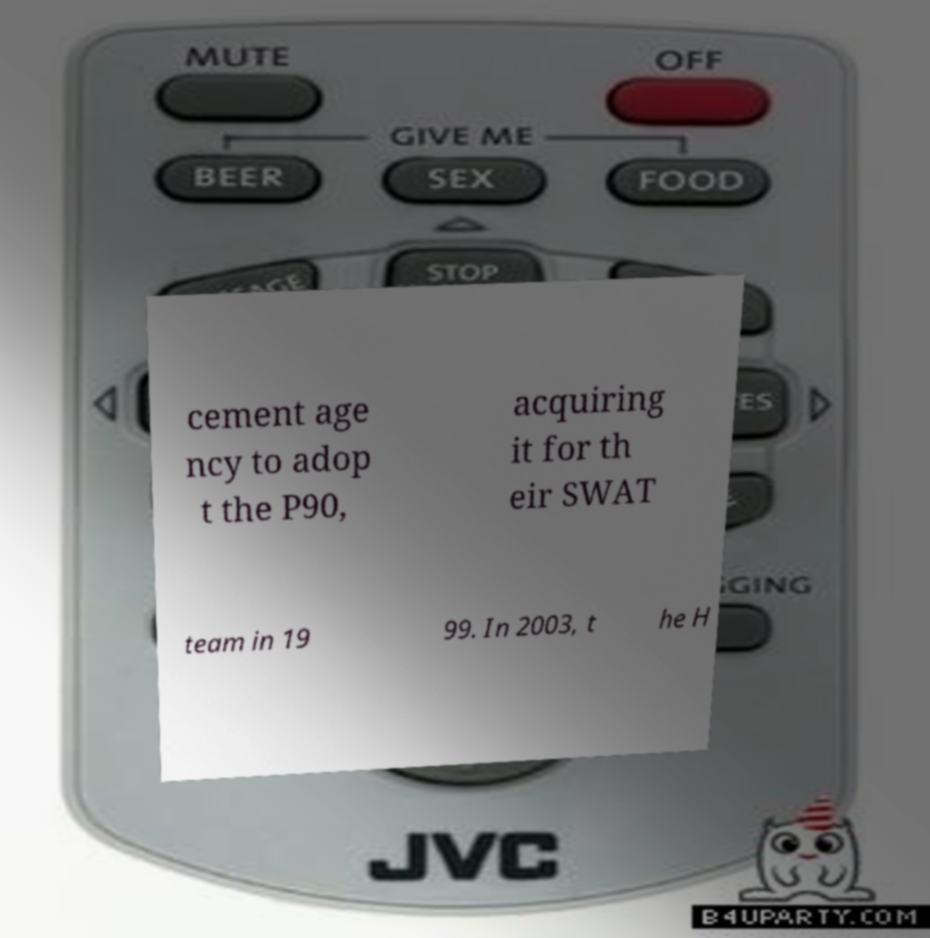Can you read and provide the text displayed in the image?This photo seems to have some interesting text. Can you extract and type it out for me? cement age ncy to adop t the P90, acquiring it for th eir SWAT team in 19 99. In 2003, t he H 